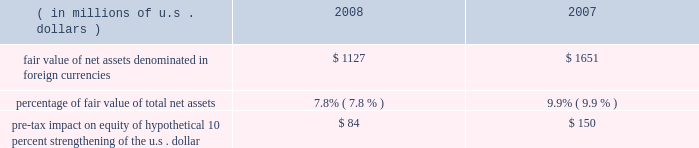Foreign currency exchange rate risk many of our non-u.s .
Companies maintain both assets and liabilities in local currencies .
Therefore , foreign exchange rate risk is generally limited to net assets denominated in those foreign currencies .
Foreign exchange rate risk is reviewed as part of our risk management process .
Locally required capital levels are invested in home currencies in order to satisfy regulatory require- ments and to support local insurance operations regardless of currency fluctuations .
The principal currencies creating foreign exchange risk for us are the british pound sterling , the euro , and the canadian dollar .
The table provides more information on our exposure to foreign exchange rate risk at december 31 , 2008 and 2007. .
Reinsurance of gmdb and gmib guarantees our net income is directly impacted by changes in the reserves calculated in connection with the reinsurance of variable annuity guarantees , primarily gmdb and gmib .
These reserves are calculated in accordance with sop 03-1 ( sop reserves ) and changes in these reserves are reflected as life and annuity benefit expense , which is included in life underwriting income .
In addition , our net income is directly impacted by the change in the fair value of the gmib liability ( fvl ) , which is classified as a derivative according to fas 133 .
The fair value liability established for a gmib reinsurance contract represents the differ- ence between the fair value of the contract and the sop 03-1 reserves .
Changes in the fair value of the gmib liability , net of associated changes in the calculated sop 03-1 reserve , are reflected as realized gains or losses .
Ace views our variable annuity reinsurance business as having a similar risk profile to that of catastrophe reinsurance , with the probability of long-term economic loss relatively small at the time of pricing .
Adverse changes in market factors and policyholder behavior will have an impact on both life underwriting income and net income .
When evaluating these risks , we expect to be compensated for taking both the risk of a cumulative long-term economic net loss , as well as the short-term accounting variations caused by these market movements .
Therefore , we evaluate this business in terms of its long-term eco- nomic risk and reward .
The ultimate risk to the variable annuity guaranty reinsurance business is a long-term underperformance of investment returns , which can be exacerbated by a long-term reduction in interest rates .
Following a market downturn , continued market underperformance over a period of five to seven years would eventually result in a higher level of paid claims as policyholders accessed their guarantees through death or annuitization .
However , if market conditions improved following a downturn , sop 03-1 reserves and fair value liability would fall reflecting a decreased likelihood of future claims , which would result in an increase in both life underwriting income and net income .
As of december 31 , 2008 , management established the sop 03-1 reserve based on the benefit ratio calculated using actual market values at december 31 , 2008 .
Management exercises judgment in determining the extent to which short-term market movements impact the sop 03-1 reserve .
The sop 03-1 reserve is based on the calculation of a long-term benefit ratio ( or loss ratio ) for the variable annuity guarantee reinsurance .
Despite the long-term nature of the risk the benefit ratio calculation is impacted by short-term market movements that may be judged by management to be temporary or transient .
Management will , in keeping with the language in sop 03-1 , regularly examine both quantitative and qualitative analysis and management will determine if , in its judgment , the change in the calculated benefit ratio is of sufficient magnitude and has persisted for a sufficient duration to warrant a change in the benefit ratio used to establish the sop 03-1 reserve .
This has no impact on either premium received or claims paid nor does it impact the long-term profit or loss of the variable annuity guaran- tee reinsurance .
The sop 03-1 reserve and fair value liability calculations are directly affected by market factors , including equity levels , interest rate levels , credit risk and implied volatilities , as well as policyholder behaviors , such as annuitization and lapse rates .
The table below shows the sensitivity , as of december 31 , 2008 , of the sop 03-1 reserves and fair value liability associated with the variable annuity guarantee reinsurance portfolio .
In addition , the tables below show the sensitivity of the fair value of specific derivative instruments held ( hedge value ) , which includes instruments purchased in january 2009 , to partially offset the risk in the variable annuity guarantee reinsurance portfolio .
Although these derivatives do not receive hedge accounting treatment , some portion of the change in value may be used to offset changes in the sop 03-1 reserve. .
What is percentage change in fair value of net assets denominated in foreign currencies from 2007 to 2008? 
Computations: ((1127 - 1651) / 1651)
Answer: -0.31738. 